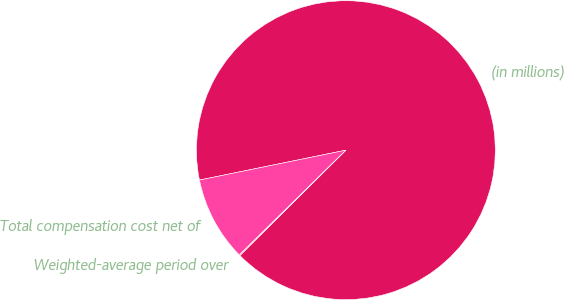<chart> <loc_0><loc_0><loc_500><loc_500><pie_chart><fcel>(in millions)<fcel>Total compensation cost net of<fcel>Weighted-average period over<nl><fcel>90.75%<fcel>9.16%<fcel>0.09%<nl></chart> 